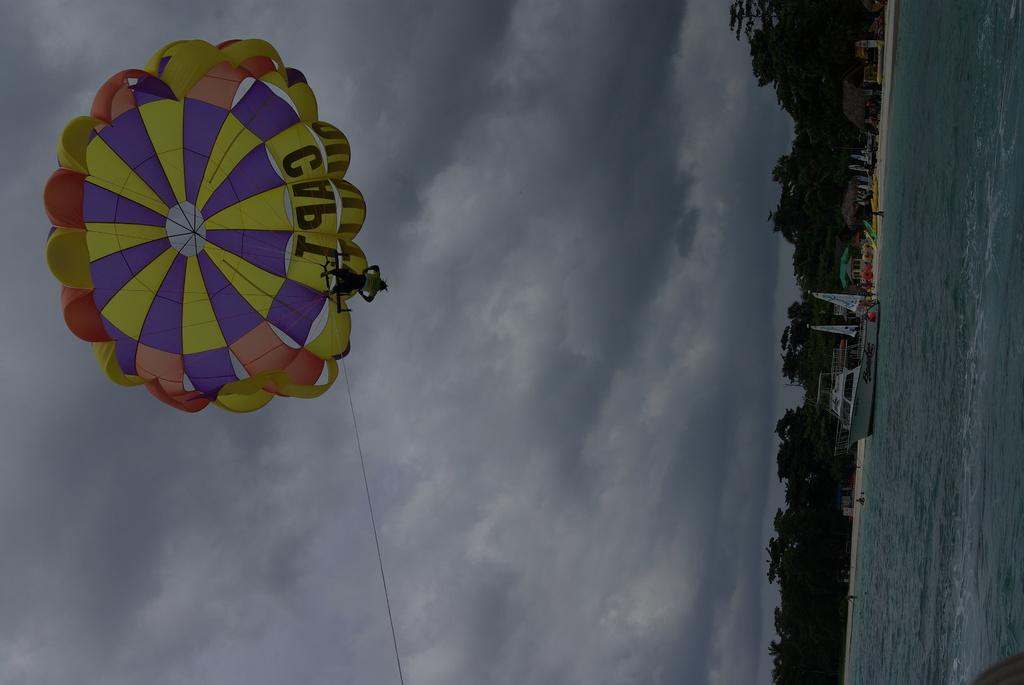What can be seen floating on the water in the image? There are boats on the water in the image. What type of natural scenery is visible in the background of the image? There are trees in the background of the image. What is the object visible at the top of the image? A parachute is visible at the top of the image. How many items can be found in the pocket of the person in the image? There is no person present in the image, so it is impossible to determine what might be in their pocket. What type of food is being consumed by the person in the image? There is no person present in the image, so it is impossible to determine if anyone is eating or what they might be eating. 